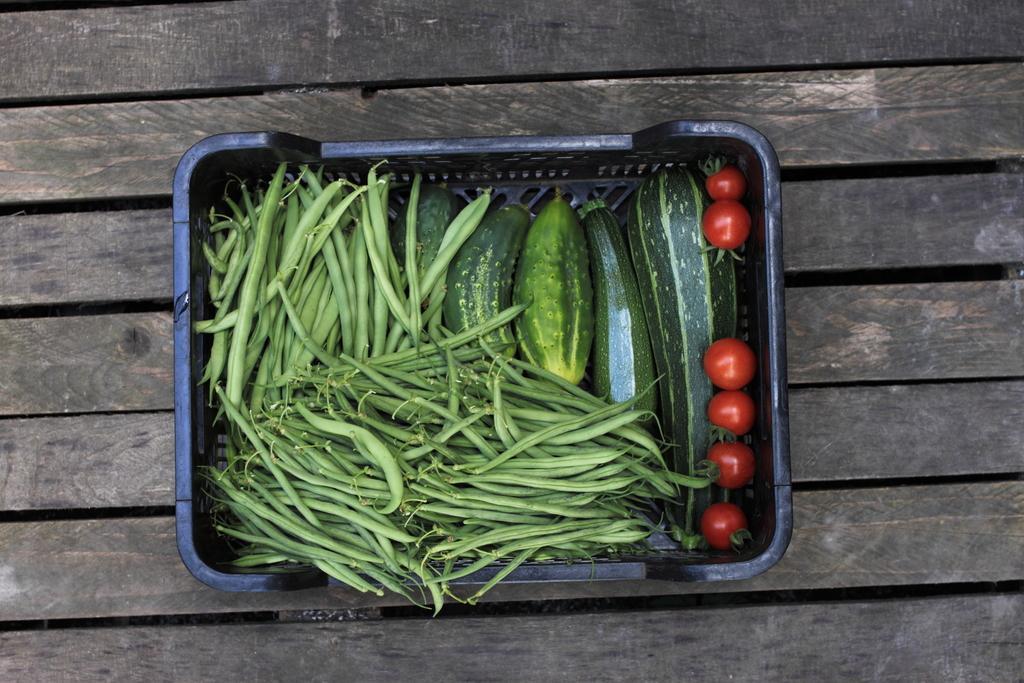Could you give a brief overview of what you see in this image? In the center of the image we can see a wooden object. On the wooden object, we can see a basket. In the basket, we can see the vegetables. 